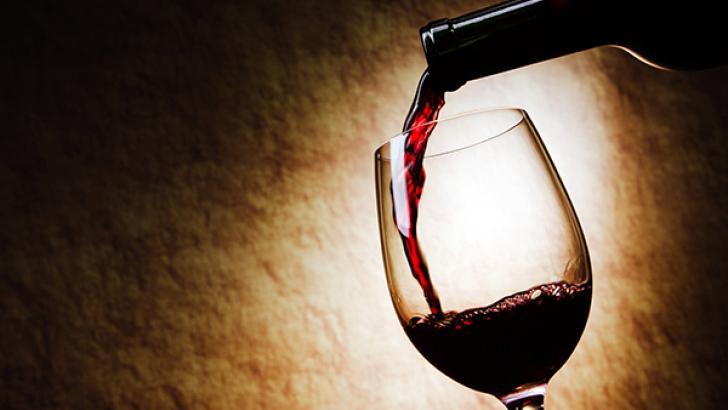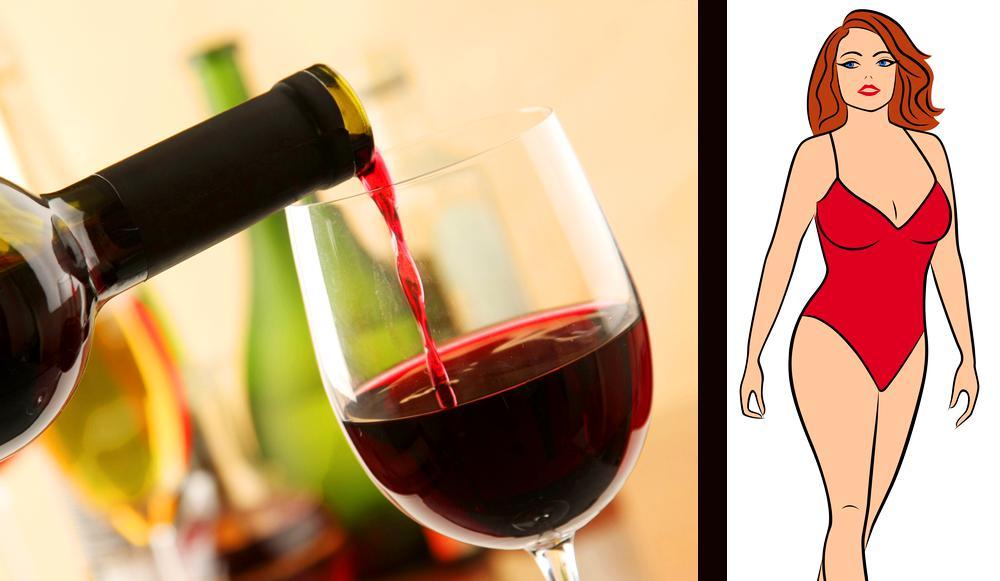The first image is the image on the left, the second image is the image on the right. For the images shown, is this caption "One of the images shows red wine being poured by a bottle placed at the left of the wine glass." true? Answer yes or no. Yes. The first image is the image on the left, the second image is the image on the right. Evaluate the accuracy of this statement regarding the images: "Wine is shown flowing from the bottle into the glass in exactly one image, and both images include a glass of wine and at least one bottle.". Is it true? Answer yes or no. No. 